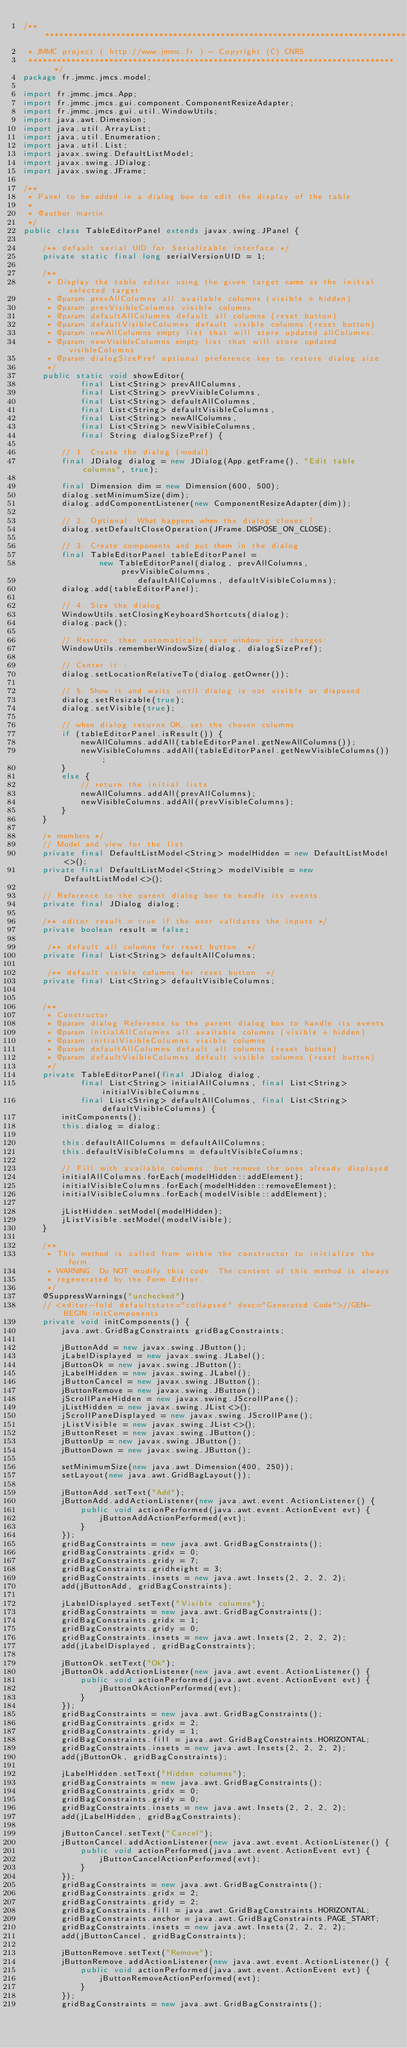Convert code to text. <code><loc_0><loc_0><loc_500><loc_500><_Java_>/** *****************************************************************************
 * JMMC project ( http://www.jmmc.fr ) - Copyright (C) CNRS.
 ***************************************************************************** */
package fr.jmmc.jmcs.model;

import fr.jmmc.jmcs.App;
import fr.jmmc.jmcs.gui.component.ComponentResizeAdapter;
import fr.jmmc.jmcs.gui.util.WindowUtils;
import java.awt.Dimension;
import java.util.ArrayList;
import java.util.Enumeration;
import java.util.List;
import javax.swing.DefaultListModel;
import javax.swing.JDialog;
import javax.swing.JFrame;

/**
 * Panel to be added in a dialog box to edit the display of the table
 *
 * @author martin
 */
public class TableEditorPanel extends javax.swing.JPanel {

    /** default serial UID for Serializable interface */
    private static final long serialVersionUID = 1;

    /**
     * Display the table editor using the given target name as the initial selected target
     * @param prevAllColumns all available columns (visible + hidden)
     * @param prevVisibleColumns visible columns
     * @param defaultAllColumns default all columns (reset button)
     * @param defaultVisibleColumns default visible columns (reset button)
     * @param newAllColumns empty list that will store updated allColumns.
     * @param newVisibleColumns empty list that will store updated visibleColumns
     * @param dialogSizePref optional preference key to restore dialog size
     */
    public static void showEditor(
            final List<String> prevAllColumns,
            final List<String> prevVisibleColumns,
            final List<String> defaultAllColumns,
            final List<String> defaultVisibleColumns,
            final List<String> newAllColumns,
            final List<String> newVisibleColumns,
            final String dialogSizePref) {

        // 1. Create the dialog (modal):
        final JDialog dialog = new JDialog(App.getFrame(), "Edit table columns", true);

        final Dimension dim = new Dimension(600, 500);
        dialog.setMinimumSize(dim);
        dialog.addComponentListener(new ComponentResizeAdapter(dim));

        // 2. Optional: What happens when the dialog closes ?
        dialog.setDefaultCloseOperation(JFrame.DISPOSE_ON_CLOSE);

        // 3. Create components and put them in the dialog
        final TableEditorPanel tableEditorPanel = 
                new TableEditorPanel(dialog, prevAllColumns, prevVisibleColumns, 
                        defaultAllColumns, defaultVisibleColumns);
        dialog.add(tableEditorPanel);

        // 4. Size the dialog.
        WindowUtils.setClosingKeyboardShortcuts(dialog);
        dialog.pack();

        // Restore, then automatically save window size changes:
        WindowUtils.rememberWindowSize(dialog, dialogSizePref);

        // Center it :
        dialog.setLocationRelativeTo(dialog.getOwner());

        // 5. Show it and waits until dialog is not visible or disposed :
        dialog.setResizable(true);
        dialog.setVisible(true);

        // when dialog returns OK, set the chosen columns
        if (tableEditorPanel.isResult()) {
            newAllColumns.addAll(tableEditorPanel.getNewAllColumns());
            newVisibleColumns.addAll(tableEditorPanel.getNewVisibleColumns());
        }
        else {
            // return the initial lists
            newAllColumns.addAll(prevAllColumns);
            newVisibleColumns.addAll(prevVisibleColumns);
        }
    }

    /* members */
    // Model and view for the list
    private final DefaultListModel<String> modelHidden = new DefaultListModel<>();
    private final DefaultListModel<String> modelVisible = new DefaultListModel<>();

    // Reference to the parent dialog box to handle its events
    private final JDialog dialog;

    /** editor result = true if the user validates the inputs */
    private boolean result = false;
    
     /** default all columns for reset button. */
    private final List<String> defaultAllColumns;
    
     /** default visible columns for reset button. */
    private final List<String> defaultVisibleColumns;
    

    /**
     * Constructor
     * @param dialog Reference to the parent dialog box to handle its events
     * @param initialAllColumns all available columns (visible + hidden)
     * @param initialVisibleColumns visible columns
     * @param defaultAllColumns default all columns (reset button)
     * @param defaultVisibleColumns default visible columns (reset button)
     */
    private TableEditorPanel(final JDialog dialog, 
            final List<String> initialAllColumns, final List<String> initialVisibleColumns,
            final List<String> defaultAllColumns, final List<String> defaultVisibleColumns) {
        initComponents();
        this.dialog = dialog;
        
        this.defaultAllColumns = defaultAllColumns;
        this.defaultVisibleColumns = defaultVisibleColumns;

        // Fill with available columns, but remove the ones already displayed
        initialAllColumns.forEach(modelHidden::addElement);
        initialVisibleColumns.forEach(modelHidden::removeElement);
        initialVisibleColumns.forEach(modelVisible::addElement);

        jListHidden.setModel(modelHidden);
        jListVisible.setModel(modelVisible);
    }

    /**
     * This method is called from within the constructor to initialize the form.
     * WARNING: Do NOT modify this code. The content of this method is always
     * regenerated by the Form Editor.
     */
    @SuppressWarnings("unchecked")
    // <editor-fold defaultstate="collapsed" desc="Generated Code">//GEN-BEGIN:initComponents
    private void initComponents() {
        java.awt.GridBagConstraints gridBagConstraints;

        jButtonAdd = new javax.swing.JButton();
        jLabelDisplayed = new javax.swing.JLabel();
        jButtonOk = new javax.swing.JButton();
        jLabelHidden = new javax.swing.JLabel();
        jButtonCancel = new javax.swing.JButton();
        jButtonRemove = new javax.swing.JButton();
        jScrollPaneHidden = new javax.swing.JScrollPane();
        jListHidden = new javax.swing.JList<>();
        jScrollPaneDisplayed = new javax.swing.JScrollPane();
        jListVisible = new javax.swing.JList<>();
        jButtonReset = new javax.swing.JButton();
        jButtonUp = new javax.swing.JButton();
        jButtonDown = new javax.swing.JButton();

        setMinimumSize(new java.awt.Dimension(400, 250));
        setLayout(new java.awt.GridBagLayout());

        jButtonAdd.setText("Add");
        jButtonAdd.addActionListener(new java.awt.event.ActionListener() {
            public void actionPerformed(java.awt.event.ActionEvent evt) {
                jButtonAddActionPerformed(evt);
            }
        });
        gridBagConstraints = new java.awt.GridBagConstraints();
        gridBagConstraints.gridx = 0;
        gridBagConstraints.gridy = 7;
        gridBagConstraints.gridheight = 3;
        gridBagConstraints.insets = new java.awt.Insets(2, 2, 2, 2);
        add(jButtonAdd, gridBagConstraints);

        jLabelDisplayed.setText("Visible columns");
        gridBagConstraints = new java.awt.GridBagConstraints();
        gridBagConstraints.gridx = 1;
        gridBagConstraints.gridy = 0;
        gridBagConstraints.insets = new java.awt.Insets(2, 2, 2, 2);
        add(jLabelDisplayed, gridBagConstraints);

        jButtonOk.setText("Ok");
        jButtonOk.addActionListener(new java.awt.event.ActionListener() {
            public void actionPerformed(java.awt.event.ActionEvent evt) {
                jButtonOkActionPerformed(evt);
            }
        });
        gridBagConstraints = new java.awt.GridBagConstraints();
        gridBagConstraints.gridx = 2;
        gridBagConstraints.gridy = 1;
        gridBagConstraints.fill = java.awt.GridBagConstraints.HORIZONTAL;
        gridBagConstraints.insets = new java.awt.Insets(2, 2, 2, 2);
        add(jButtonOk, gridBagConstraints);

        jLabelHidden.setText("Hidden columns");
        gridBagConstraints = new java.awt.GridBagConstraints();
        gridBagConstraints.gridx = 0;
        gridBagConstraints.gridy = 0;
        gridBagConstraints.insets = new java.awt.Insets(2, 2, 2, 2);
        add(jLabelHidden, gridBagConstraints);

        jButtonCancel.setText("Cancel");
        jButtonCancel.addActionListener(new java.awt.event.ActionListener() {
            public void actionPerformed(java.awt.event.ActionEvent evt) {
                jButtonCancelActionPerformed(evt);
            }
        });
        gridBagConstraints = new java.awt.GridBagConstraints();
        gridBagConstraints.gridx = 2;
        gridBagConstraints.gridy = 2;
        gridBagConstraints.fill = java.awt.GridBagConstraints.HORIZONTAL;
        gridBagConstraints.anchor = java.awt.GridBagConstraints.PAGE_START;
        gridBagConstraints.insets = new java.awt.Insets(2, 2, 2, 2);
        add(jButtonCancel, gridBagConstraints);

        jButtonRemove.setText("Remove");
        jButtonRemove.addActionListener(new java.awt.event.ActionListener() {
            public void actionPerformed(java.awt.event.ActionEvent evt) {
                jButtonRemoveActionPerformed(evt);
            }
        });
        gridBagConstraints = new java.awt.GridBagConstraints();</code> 